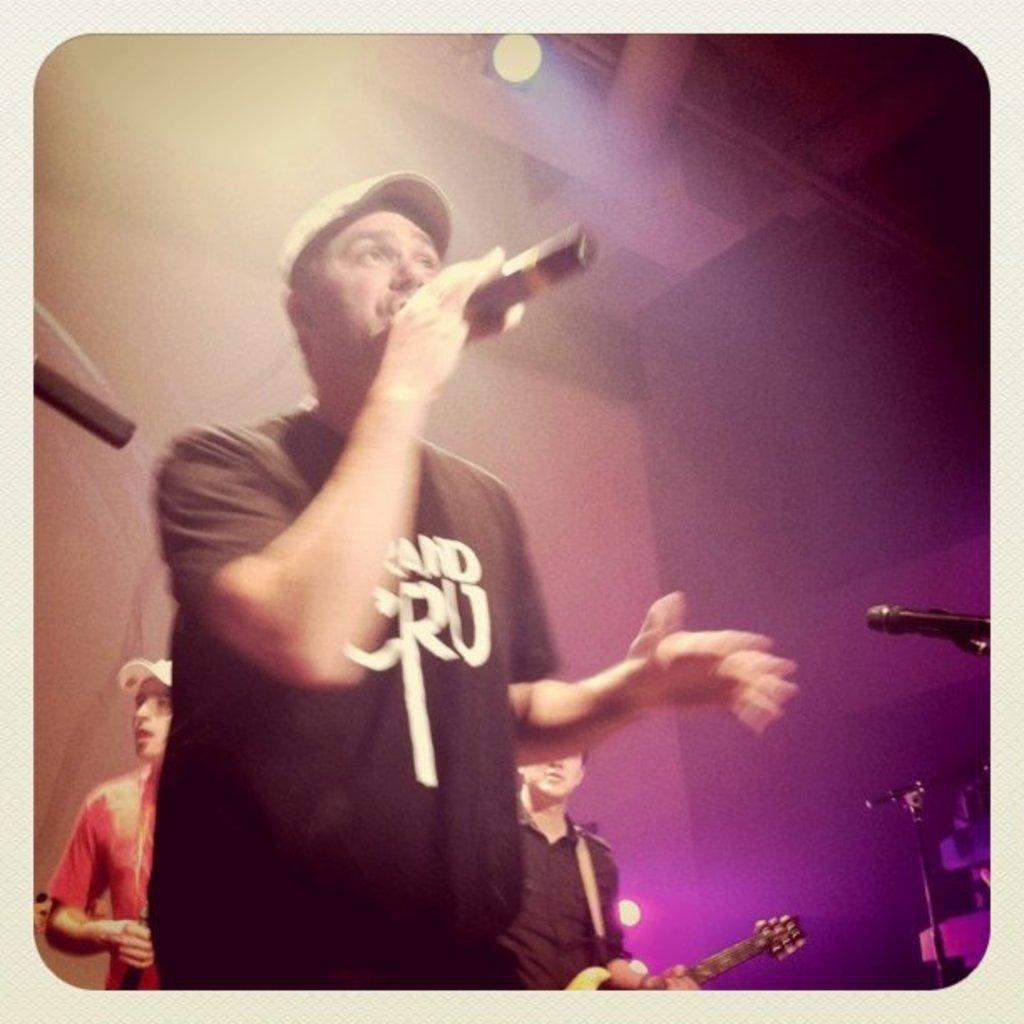What is the person in the foreground holding in the image? The person is holding a mike. Can you describe the person's attire? The person is wearing a hat and a black t-shirt. How many people are visible in the background? There are two persons in the background. What can be seen in the background besides the people? There is a wall and a light in the background. Is the person in the image wearing a mask to protect against pollution? There is no indication in the image that the person is wearing a mask to protect against pollution. 